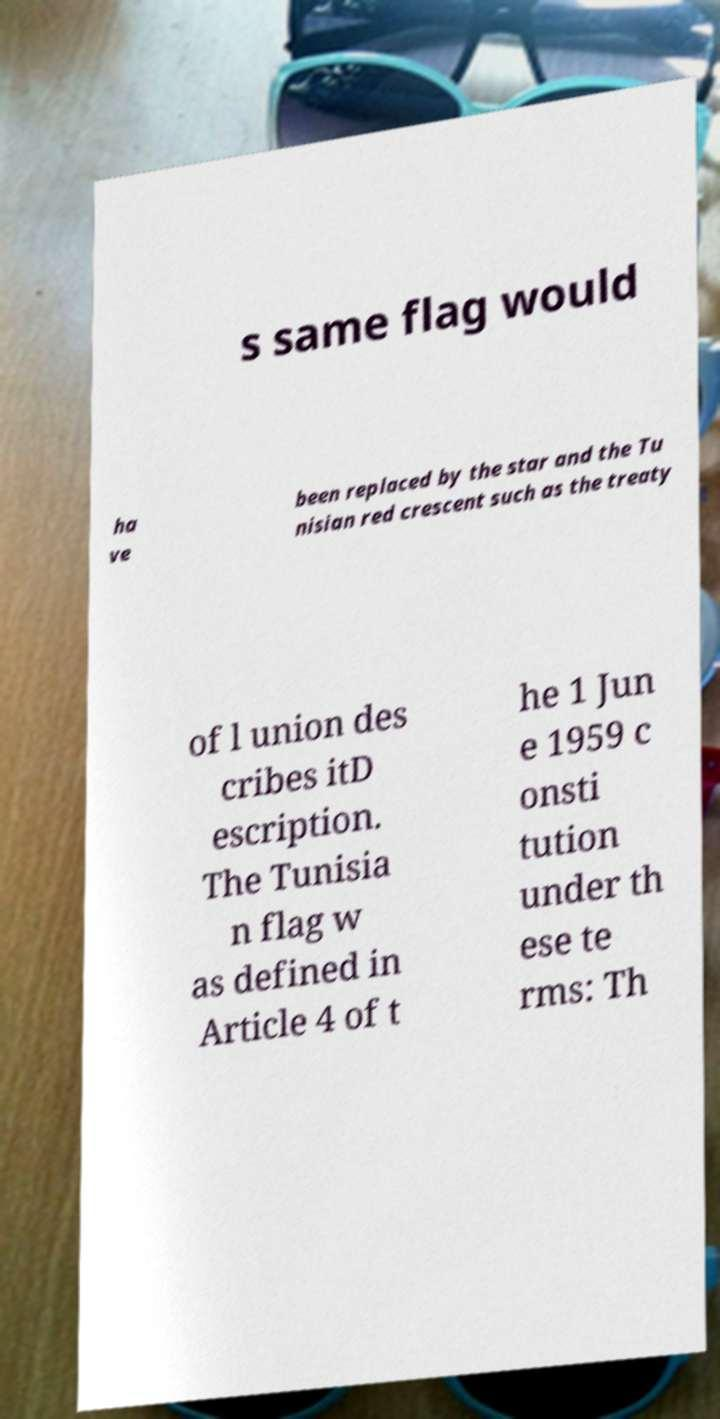For documentation purposes, I need the text within this image transcribed. Could you provide that? s same flag would ha ve been replaced by the star and the Tu nisian red crescent such as the treaty of l union des cribes itD escription. The Tunisia n flag w as defined in Article 4 of t he 1 Jun e 1959 c onsti tution under th ese te rms: Th 